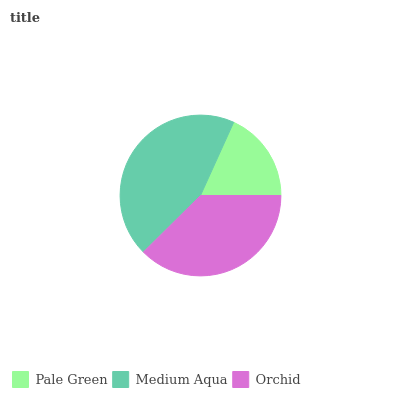Is Pale Green the minimum?
Answer yes or no. Yes. Is Medium Aqua the maximum?
Answer yes or no. Yes. Is Orchid the minimum?
Answer yes or no. No. Is Orchid the maximum?
Answer yes or no. No. Is Medium Aqua greater than Orchid?
Answer yes or no. Yes. Is Orchid less than Medium Aqua?
Answer yes or no. Yes. Is Orchid greater than Medium Aqua?
Answer yes or no. No. Is Medium Aqua less than Orchid?
Answer yes or no. No. Is Orchid the high median?
Answer yes or no. Yes. Is Orchid the low median?
Answer yes or no. Yes. Is Medium Aqua the high median?
Answer yes or no. No. Is Medium Aqua the low median?
Answer yes or no. No. 